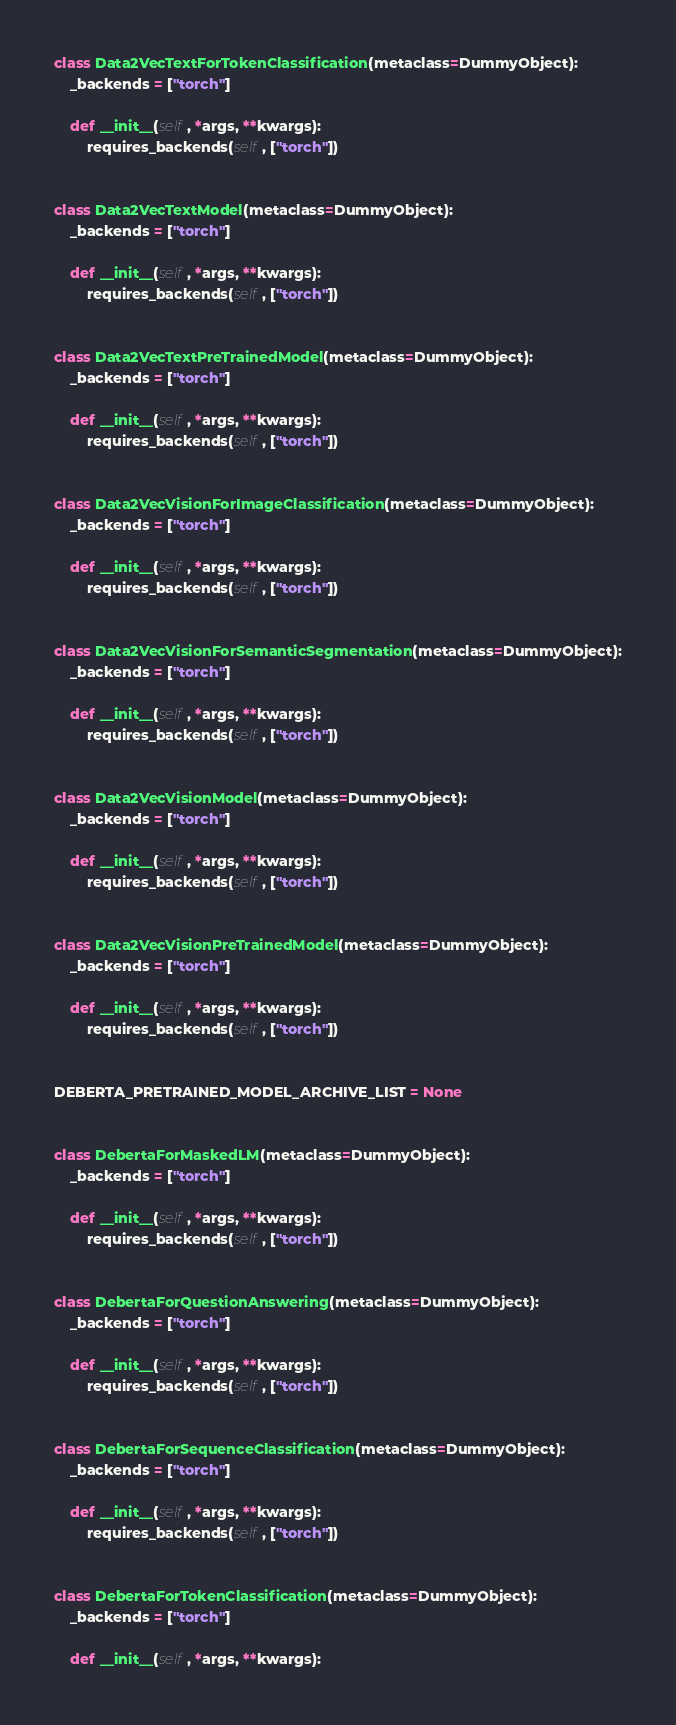<code> <loc_0><loc_0><loc_500><loc_500><_Python_>
class Data2VecTextForTokenClassification(metaclass=DummyObject):
    _backends = ["torch"]

    def __init__(self, *args, **kwargs):
        requires_backends(self, ["torch"])


class Data2VecTextModel(metaclass=DummyObject):
    _backends = ["torch"]

    def __init__(self, *args, **kwargs):
        requires_backends(self, ["torch"])


class Data2VecTextPreTrainedModel(metaclass=DummyObject):
    _backends = ["torch"]

    def __init__(self, *args, **kwargs):
        requires_backends(self, ["torch"])


class Data2VecVisionForImageClassification(metaclass=DummyObject):
    _backends = ["torch"]

    def __init__(self, *args, **kwargs):
        requires_backends(self, ["torch"])


class Data2VecVisionForSemanticSegmentation(metaclass=DummyObject):
    _backends = ["torch"]

    def __init__(self, *args, **kwargs):
        requires_backends(self, ["torch"])


class Data2VecVisionModel(metaclass=DummyObject):
    _backends = ["torch"]

    def __init__(self, *args, **kwargs):
        requires_backends(self, ["torch"])


class Data2VecVisionPreTrainedModel(metaclass=DummyObject):
    _backends = ["torch"]

    def __init__(self, *args, **kwargs):
        requires_backends(self, ["torch"])


DEBERTA_PRETRAINED_MODEL_ARCHIVE_LIST = None


class DebertaForMaskedLM(metaclass=DummyObject):
    _backends = ["torch"]

    def __init__(self, *args, **kwargs):
        requires_backends(self, ["torch"])


class DebertaForQuestionAnswering(metaclass=DummyObject):
    _backends = ["torch"]

    def __init__(self, *args, **kwargs):
        requires_backends(self, ["torch"])


class DebertaForSequenceClassification(metaclass=DummyObject):
    _backends = ["torch"]

    def __init__(self, *args, **kwargs):
        requires_backends(self, ["torch"])


class DebertaForTokenClassification(metaclass=DummyObject):
    _backends = ["torch"]

    def __init__(self, *args, **kwargs):</code> 